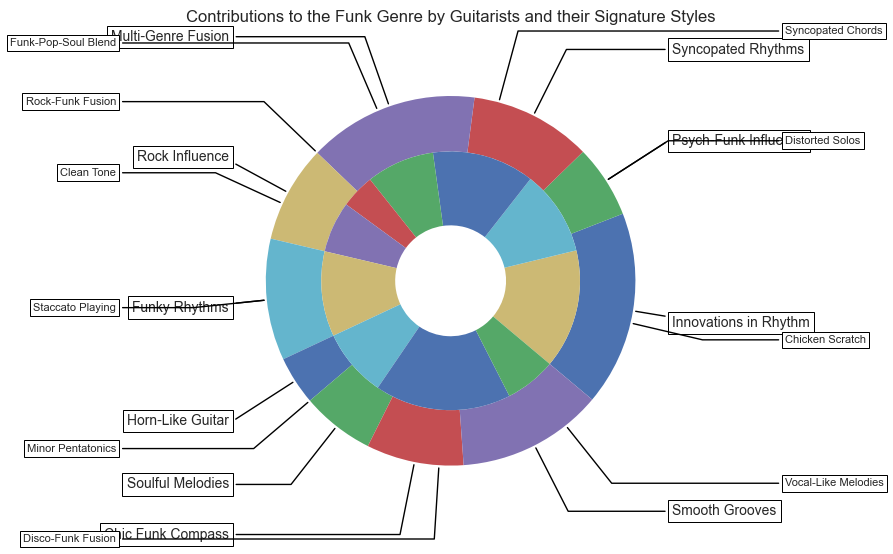Which guitarist contributed the most to the genre in terms of percentage? To determine which guitarist contributed the most, look for the largest single segment in the nested pie chart. The outer layer of the chart shows that Nile Rodgers has the largest segment with a contribution of 40%.
Answer: Nile Rodgers How does Jimmy Nolen’s contribution to "Innovations in Rhythm" compare to Leo Nocentelli's contribution to "Syncopated Rhythms"? Jimmy Nolen's contribution is represented by a segment showing 35%, whereas Leo Nocentelli's contribution is represented by a segment showing 30%. 35% is greater than 30%, so Jimmy Nolen's contribution is larger.
Answer: Jimmy Nolen’s contribution is larger What is the total percentage contributed by guitarists with a "fusion" style (both "Funk-Pop-Soul Blend" and "Rock-Funk Fusion")? To calculate this, sum the percentages of the relevant sub-categories: "Funk-Pop-Soul Blend" (20%) and "Rock-Funk Fusion" (10%). This gives 20% + 10% = 30%.
Answer: 30% Which contribution category has the smallest visual segment in the inner layer, and what is its percentage? The smallest visual segment in the inner layer is indicated by the smallest slice of the pie chart, which is "Rock Influence" with a contribution of 10%.
Answer: Rock Influence, 10% Compare the contributions of "Staccato Playing" and "Clean Tone" in terms of percentage. Which is higher? "Staccato Playing" has a percentage of 25%, and "Clean Tone" has a percentage of 15%. By comparing these, 25% is greater than 15%. Therefore, "Staccato Playing" has a higher percentage.
Answer: Staccato Playing How much greater is the contribution of "Disco-Funk Fusion" compared to "Funky Rhythms"? "Disco-Funk Fusion" has a percentage of 40%, and "Funky Rhythms" has a percentage of 15%. The difference is 40% - 15% = 25%.
Answer: 25% Is the percentage contribution of "Freddie Stone" equal to the combined percentage of "Tony Maiden" and "Cory Wong"? Freddie Stone contributes 25%. Tony Maiden contributes 15%, and Cory Wong contributes 15%. The combined percentage of Tony Maiden and Cory Wong is 15% + 15% = 30%, which is not equal to 25%.
Answer: No What percentage does "Minor Pentatonics" contribute to the soul category? "Minor Pentatonics," within the "Soulful Melodies" category, contributes 20% to the overall chart.
Answer: 20% Identify the innovation style of "Eddie Hazel" and the percentage contribution it represents. Eddie Hazel's innovation style is "Distorted Solos," which contributes 25% to the chart.
Answer: Distorted Solos, 25% 